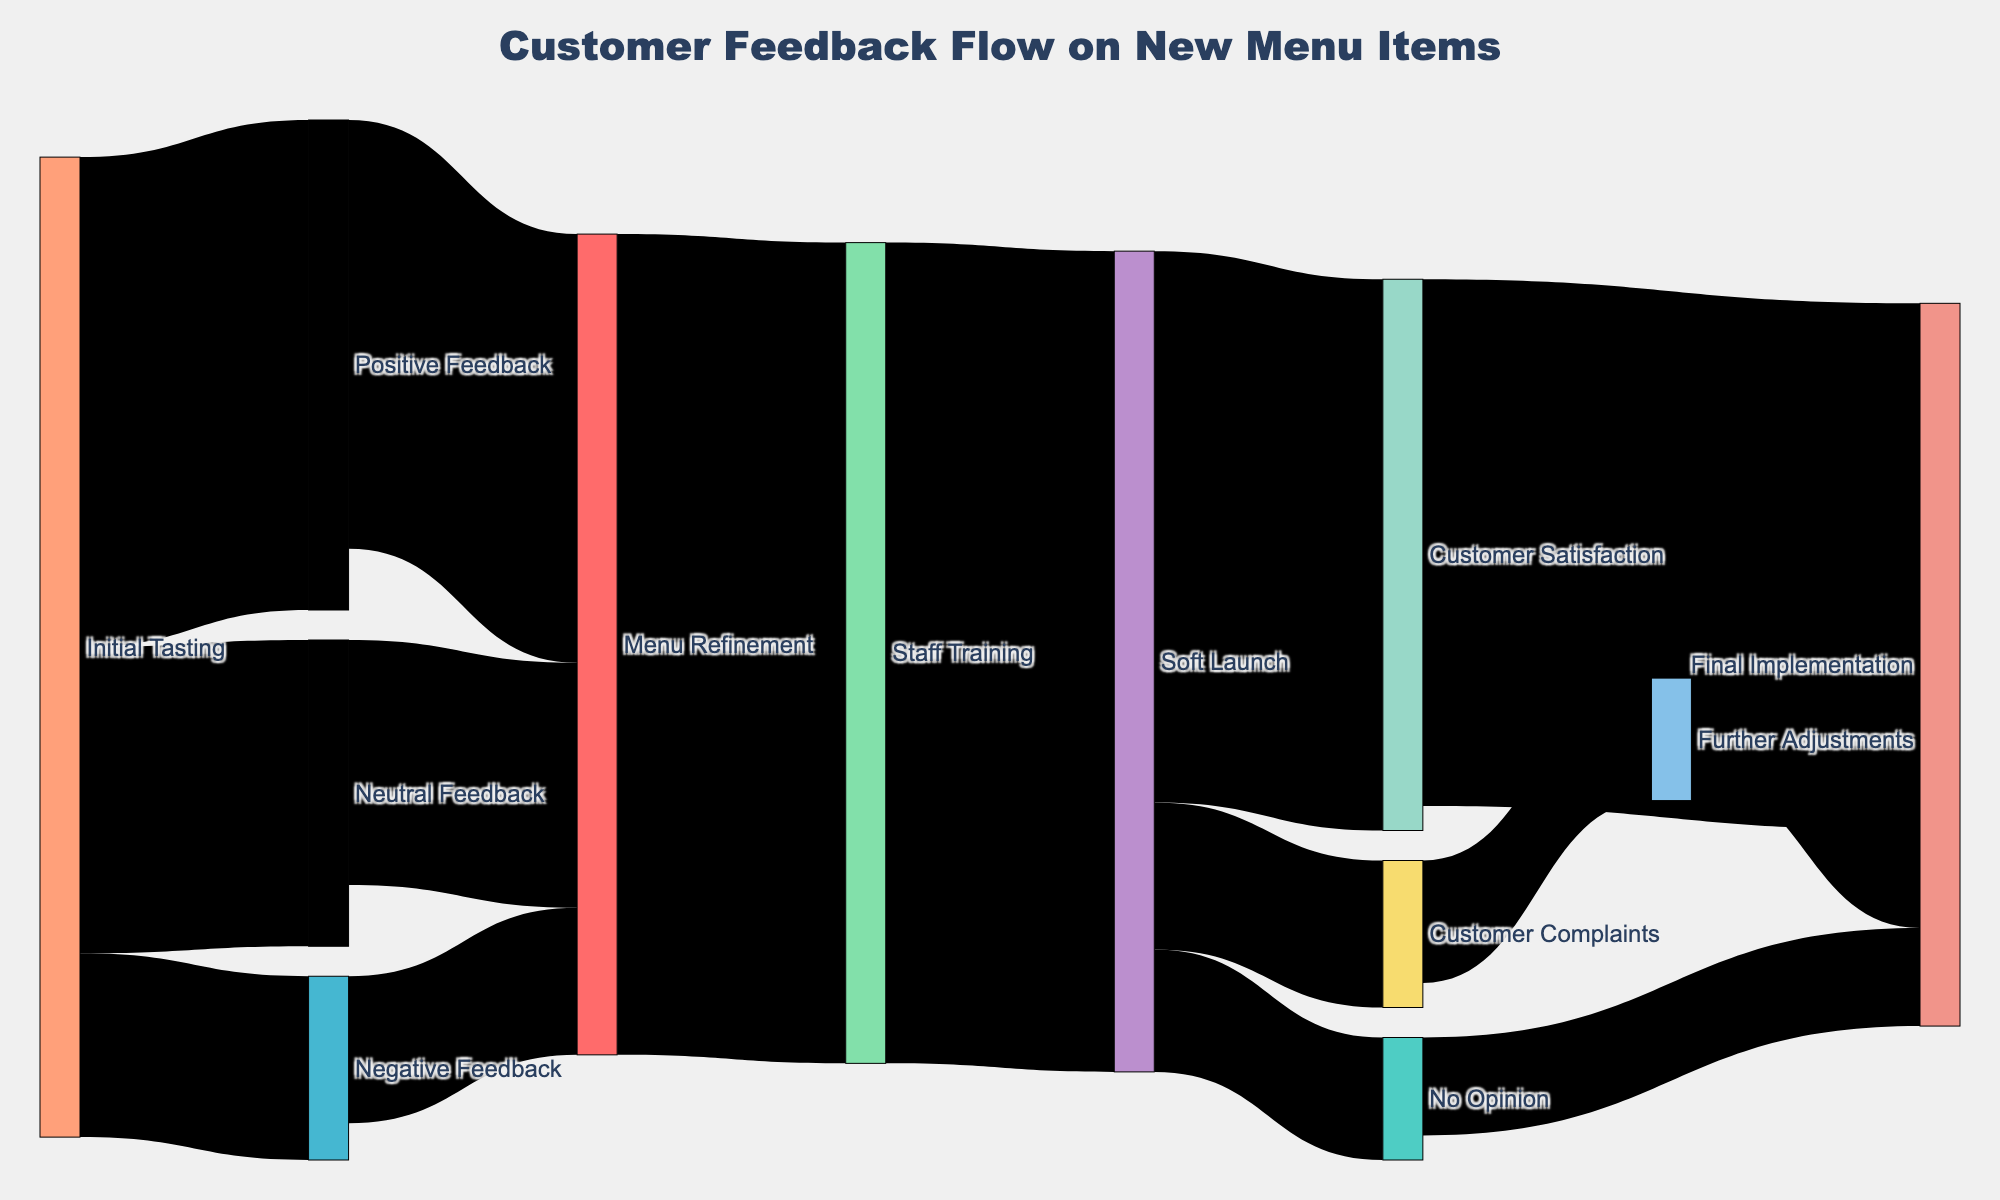What's the title of the diagram? The title is typically displayed at the top of the Sankey diagram. In this case, the title of the diagram is "Customer Feedback Flow on New Menu Items".
Answer: Customer Feedback Flow on New Menu Items How many customers gave positive feedback during the initial tasting? In the Sankey diagram, examine the flow from "Initial Tasting" to "Positive Feedback." The value associated with this link is 40.
Answer: 40 What is the total value of feedback that leads to menu refinement? Sum the values leading to "Menu Refinement" from "Positive Feedback" (35), "Negative Feedback" (12), and "Neutral Feedback" (20). 35 + 12 + 20 = 67.
Answer: 67 Which feedback category had the least number of people during the initial tasting? Look at the values of the flows from "Initial Tasting." The smallest value is 15, which corresponds to "Negative Feedback."
Answer: Negative Feedback How does the number of people giving customer satisfaction compare to those giving customer complaints during the soft launch? Compare the values flowing from "Soft Launch" to "Customer Satisfaction" (45) and "Customer Complaints" (12). 45 is greater than 12.
Answer: Customer Satisfaction is higher than Customer Complaints What percentage of customer satisfaction leads to final implementation? To find the percentage, take the value from "Customer Satisfaction" to "Final Implementation" (43) and divide by the total leading to "Customer Satisfaction" (45), then multiply by 100. (43/45) * 100 = 95.56%
Answer: 95.56% How many total customers participated in the initial tasting? Sum the values flowing from "Initial Tasting" to feedback categories: 40 (Positive) + 15 (Negative) + 25 (Neutral). 40 + 15 + 25 = 80.
Answer: 80 Which path has the highest number of transitions leading to final implementation? Trace paths leading to "Final Implementation." Paths are "Customer Satisfaction -> Final Implementation" (45), "No Opinion -> Final Implementation" (10), and "Further Adjustments -> Final Implementation" (8). The path with the highest value is "Customer Satisfaction -> Final Implementation" (43).
Answer: Customer Satisfaction -> Final Implementation What is the next step after the Menu Refinement phase? Follow the link from "Menu Refinement." The next step is "Staff Training."
Answer: Staff Training How many total transitions were there in the soft launch phase? Sum all values leading into "Soft Launch": 67 from "Staff Training". Since there is only one input, the total is simply 67.
Answer: 67 